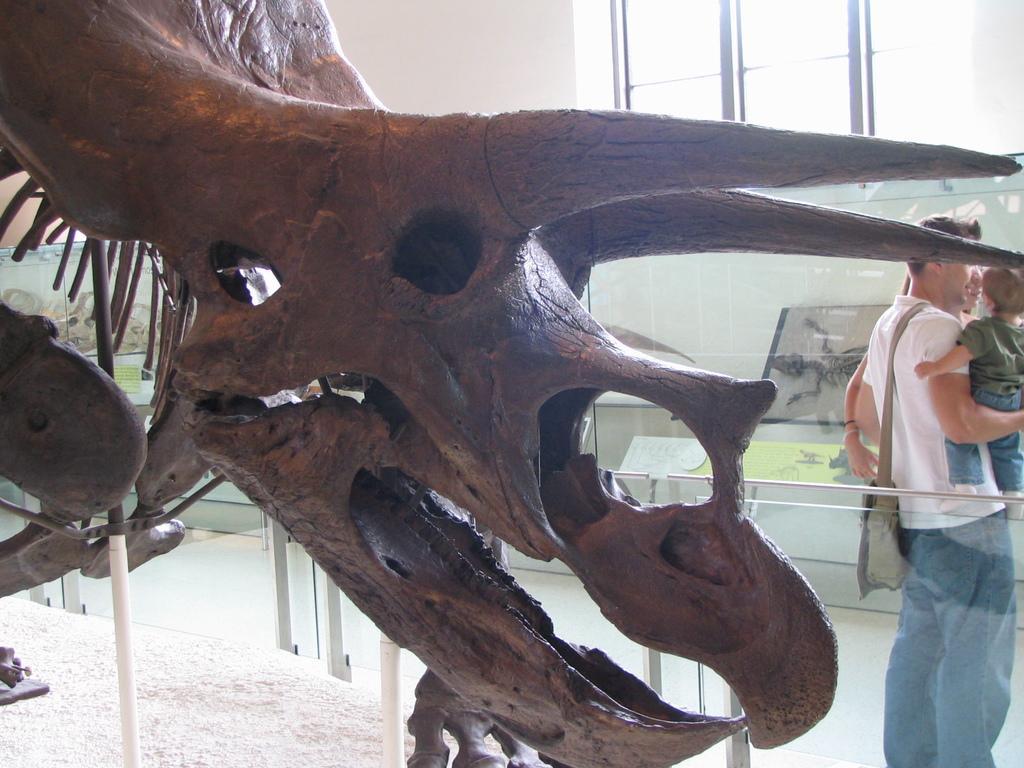Could you give a brief overview of what you see in this image? Here we can see skeleton of a dragon, glasses, and few persons. In the background we can see a wall, windows, and boards. 